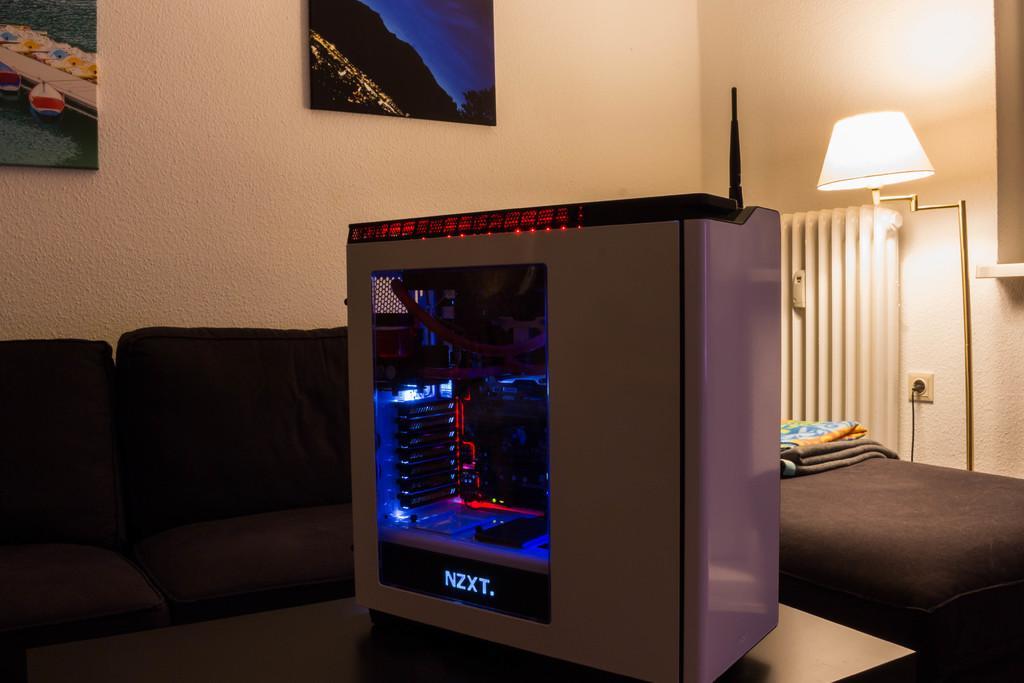In one or two sentences, can you explain what this image depicts? In this image we can see an electronic device which is placed on a table. On the backside we can see some chairs a sofa and some blankets on it. We can also see a lamp, switch board and some photo frames on a wall. 